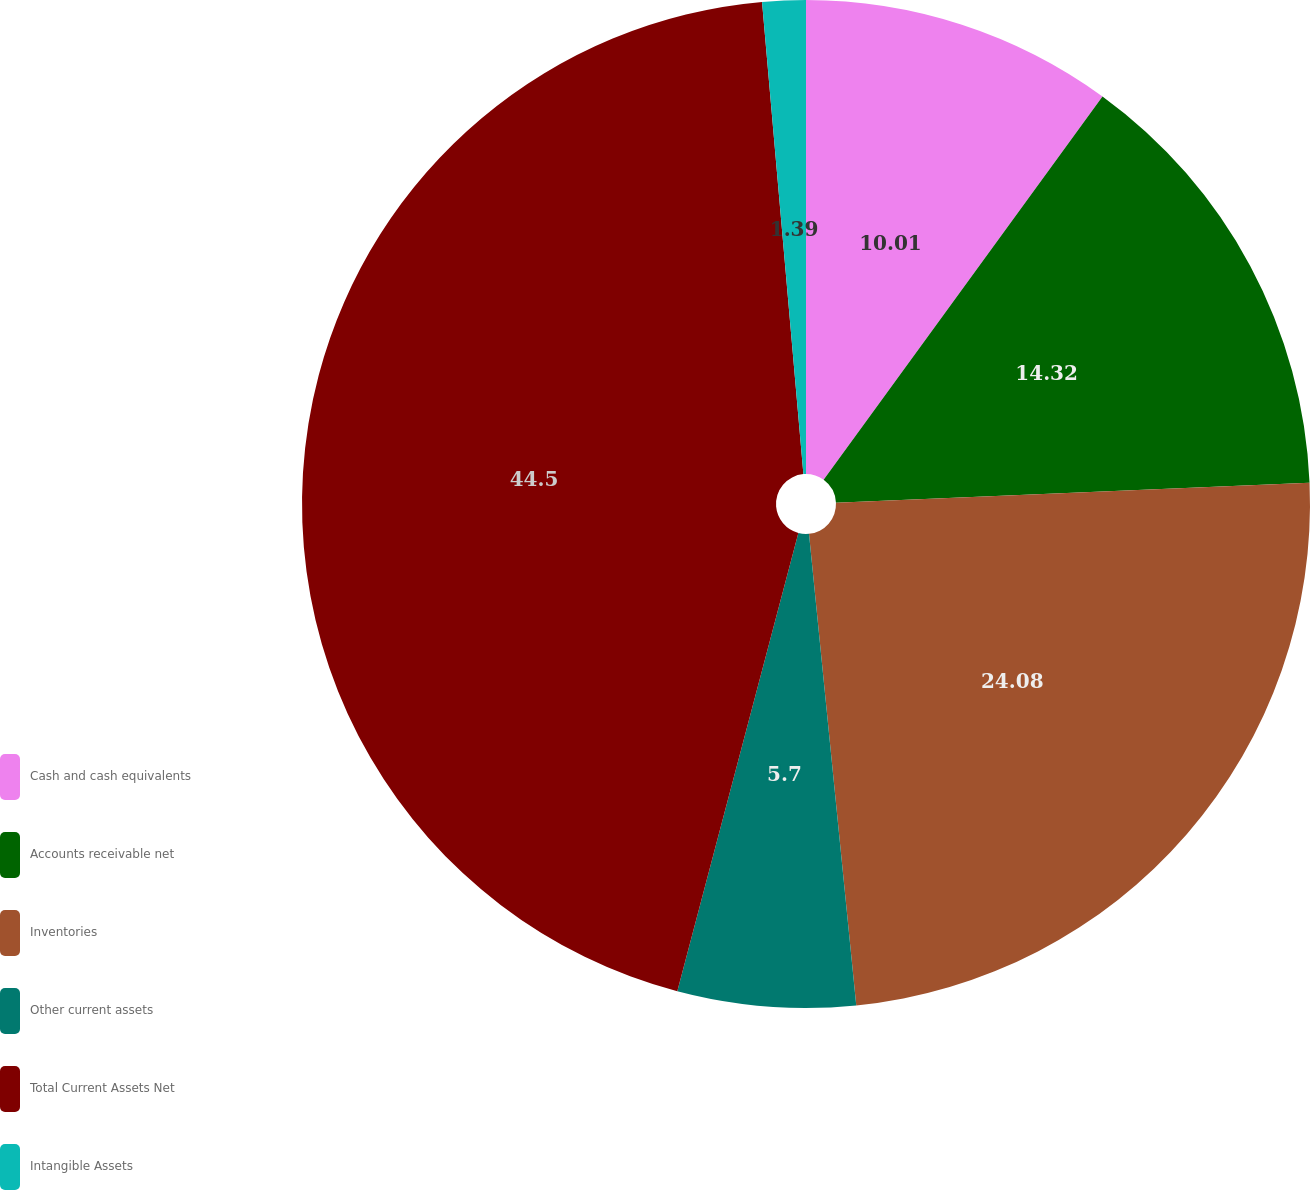Convert chart. <chart><loc_0><loc_0><loc_500><loc_500><pie_chart><fcel>Cash and cash equivalents<fcel>Accounts receivable net<fcel>Inventories<fcel>Other current assets<fcel>Total Current Assets Net<fcel>Intangible Assets<nl><fcel>10.01%<fcel>14.32%<fcel>24.08%<fcel>5.7%<fcel>44.5%<fcel>1.39%<nl></chart> 